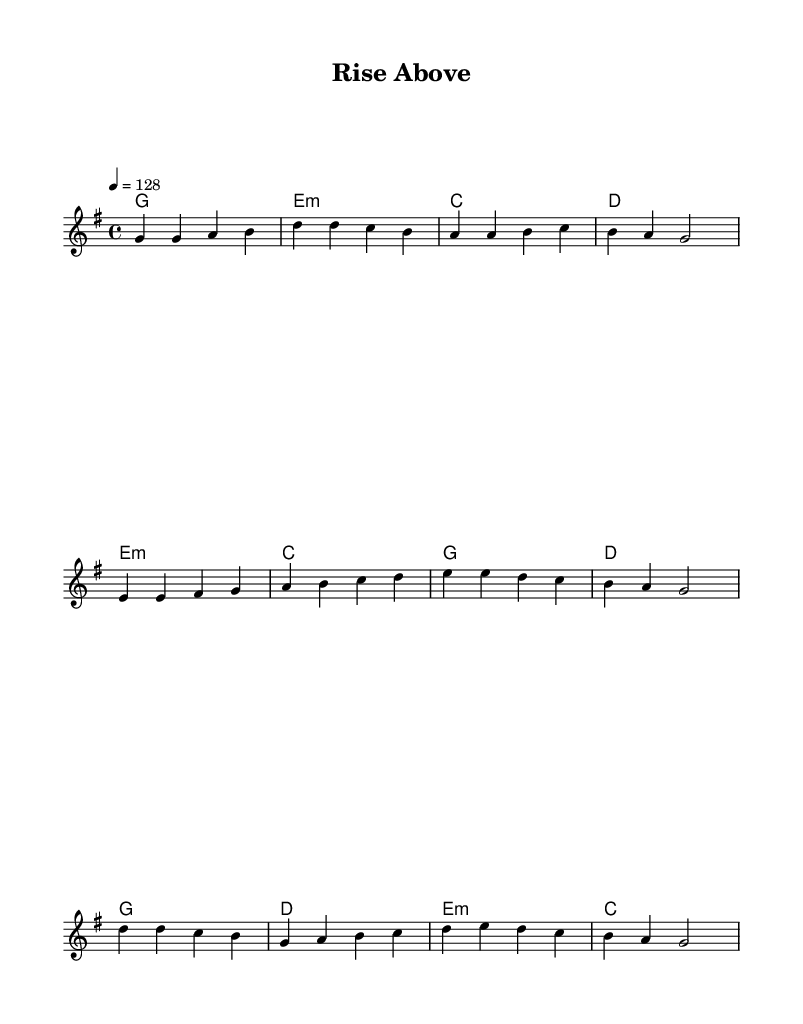What is the key signature of this music? The key signature is G major, which has one sharp (F#). This can be determined from the presence of the sharp symbol placed on the staff lines corresponding to F.
Answer: G major What is the time signature of this music? The time signature is four-four, commonly notated as 4/4. This is indicated at the beginning of the score where the 4s represent the number of beats in a measure and the type of note that gets one beat.
Answer: Four-four What is the tempo marking of this music? The tempo marking is 128 beats per minute, indicated by the tempo marking specified under the global settings. This tells musicians how fast to play the piece.
Answer: 128 How many measures are in the melody? The melody consists of twelve measures. By counting each distinct set of bar lines in the melody section, we arrive at this total.
Answer: Twelve Which chords are used in the chorus? The chords in the chorus are G, D, E minor, and C. This can be found by looking specifically at the chord mode section where the chorus part is denoted.
Answer: G, D, E minor, C What is a prominent theme expressed in this song based on the title and sheet music? A prominent theme is overcoming challenges and personal growth, as suggested by the title "Rise Above" and the upbeat melody that typically reflects positivity and resilience.
Answer: Overcoming challenges and personal growth 